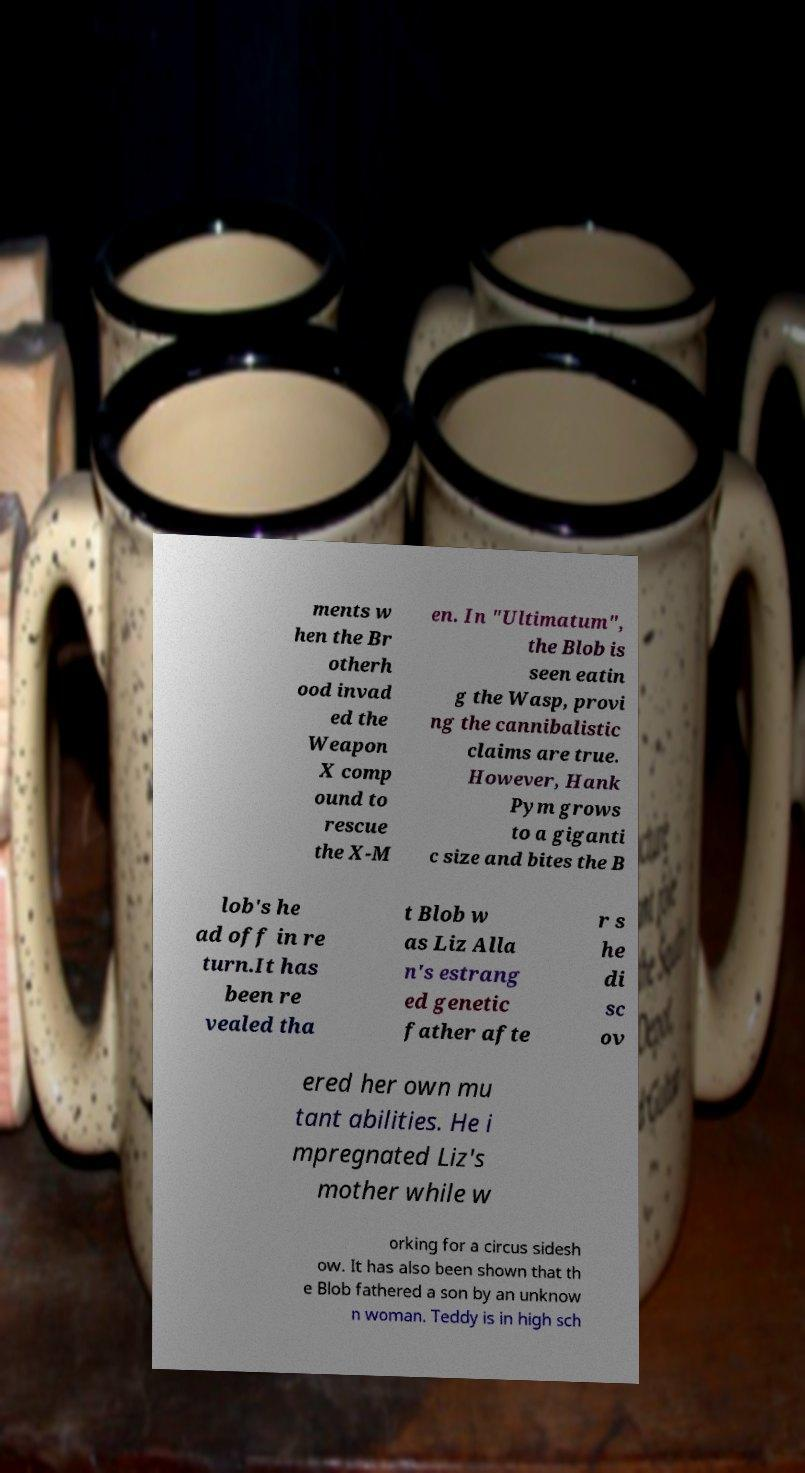There's text embedded in this image that I need extracted. Can you transcribe it verbatim? ments w hen the Br otherh ood invad ed the Weapon X comp ound to rescue the X-M en. In "Ultimatum", the Blob is seen eatin g the Wasp, provi ng the cannibalistic claims are true. However, Hank Pym grows to a giganti c size and bites the B lob's he ad off in re turn.It has been re vealed tha t Blob w as Liz Alla n's estrang ed genetic father afte r s he di sc ov ered her own mu tant abilities. He i mpregnated Liz's mother while w orking for a circus sidesh ow. It has also been shown that th e Blob fathered a son by an unknow n woman. Teddy is in high sch 